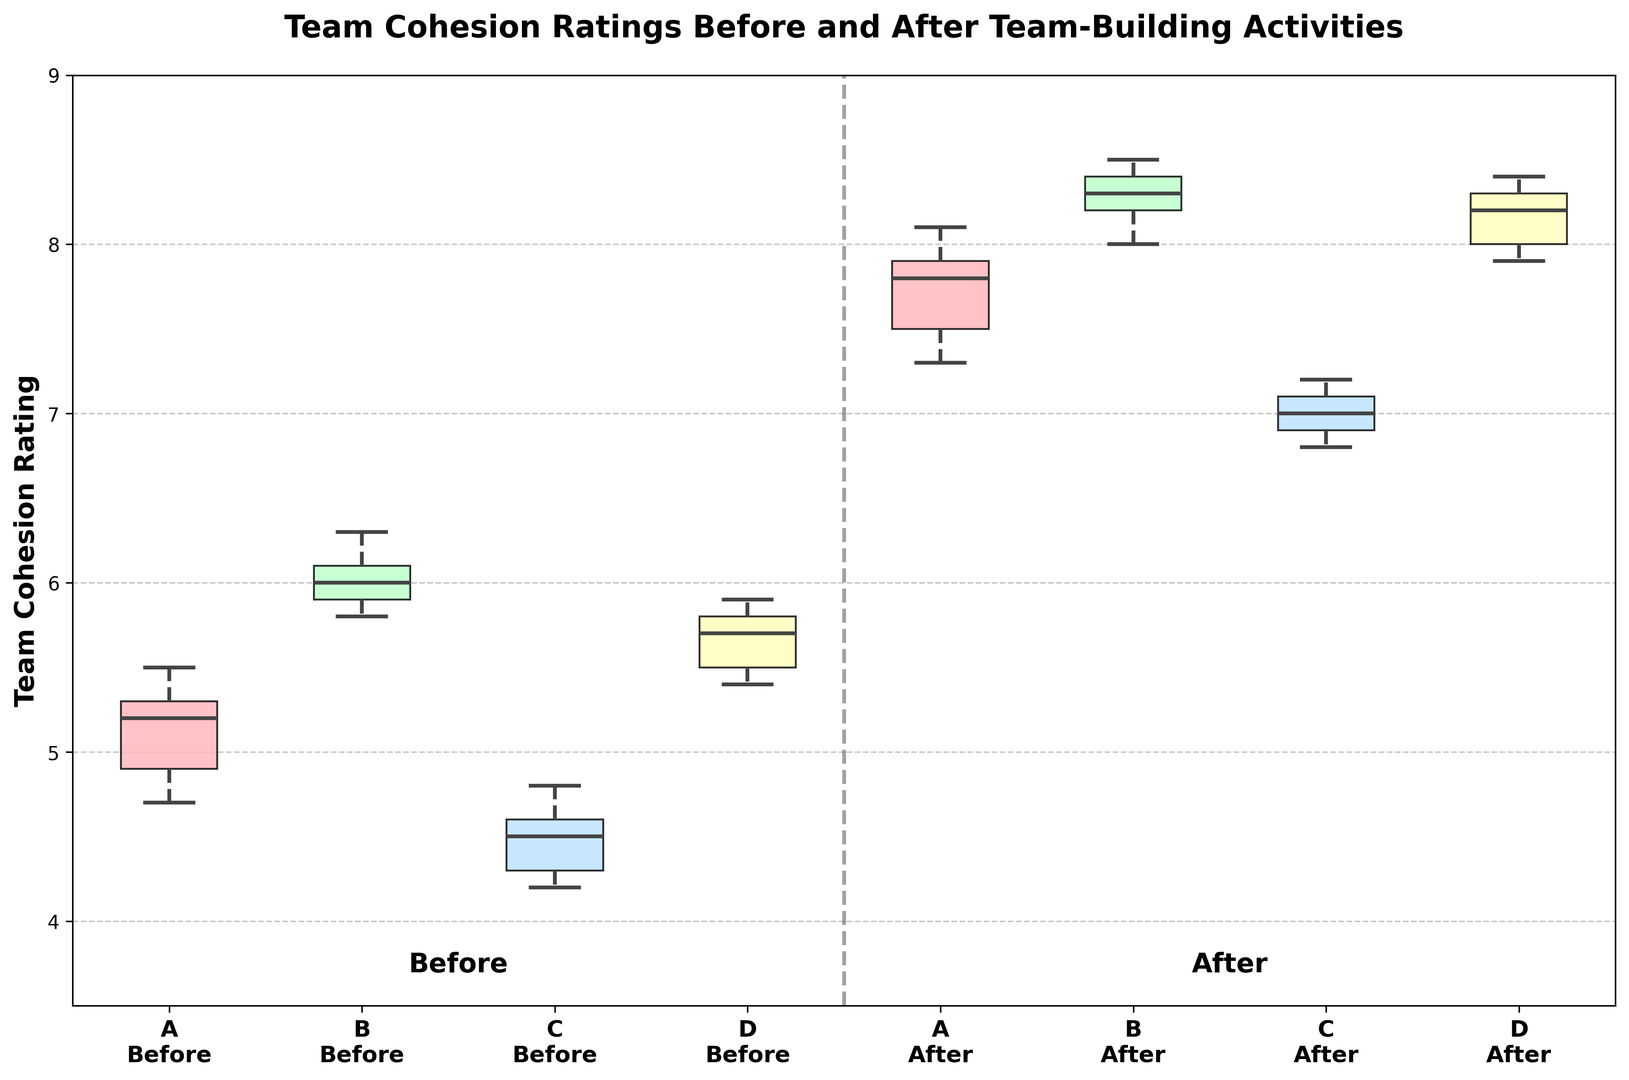What is the median team cohesion rating for Team A before the team-building activities? Locate the box plot corresponding to 'Team A - Before' and identify the central line within the box plot. This line represents the median.
Answer: 5.2 Which team shows the highest increase in median cohesion ratings after the team-building activities? Compare the 'Before' and 'After' median lines for each team. Identify which team has the largest difference between these medians. Team A’s median improves significantly, from 5.2 to 7.8, which is the highest observed increase.
Answer: Team A What are the lower and upper quartiles for Team B after the team-building activities? Locate the 'Team B - After' box plot and identify the bottom and top edges of the box, representing the lower (25th percentile) and upper (75th percentile) quartiles.
Answer: 8.0 and 8.4 Compare the range of the data for Team D before and after the team-building activities. Which one has a larger range? The range is the difference between the upper and lower whiskers. For 'Team D - Before', the range is from 5.4 to 5.9 (0.5). For 'Team D - After', the range is from 7.9 to 8.4 (0.5). Both ranges are identical.
Answer: Both are equal How does the median team cohesion rating for Team C after the activities compare to that before the activities? Identify the medians for 'Team C - Before' and 'Team C - After'. 'Team C - Before' is approximately 4.5 and 'Team C - After' is 7.0. Calculate the difference: 7.0 - 4.5.
Answer: Increased by 2.5 Are there any outliers in the 'Team D - After' ratings? Observe the 'Team D - After' box plot for any individual points that are separate from the whiskers and box. Outliers are often marked with dots. The plot shows no separate points beyond the whiskers.
Answer: No outliers Which team had the smallest interquartile range (IQR) after the team-building activities, and what is the value? The IQR is the difference between the upper and lower quartiles. Observe the boxes' height for 'Team A - After', 'Team B - After', 'Team C - After', and 'Team D - After'. 'Team C - After' has narrowest box, indicating the smallest IQR. Calculate the value: 7.1 - 6.9 = 0.2.
Answer: Team C, 0.2 Is there a significant difference between the cohesion ratings' spread for Team C before and after the activities? Compare the width of the boxes and length of whiskers in 'Team C - Before' and 'Team C - After' plots. 'Team C - Before' shows a wider spread with more extended whiskers whereas 'Team C - After' has a narrower spread.
Answer: Yes, narrower after What does the least change in median values suggest about the effectiveness of the interventions for the corresponding teams? Compare the median values before and after for all teams. The smallest change observed in Team D (5.7 to 8.2) could suggest less room for improvement or highly effective baseline cohesion.
Answer: Team D had least change (5.7 to 8.2) What can you infer about Team B's data distribution before and after the activities based on the length of their whiskers? Observe the length of whiskers in both 'Team B - Before' and 'Team B - After' plots. Before activities, they are slightly elongated, after activities, whiskers shortened indicating reduced variability.
Answer: Reduced variability after 